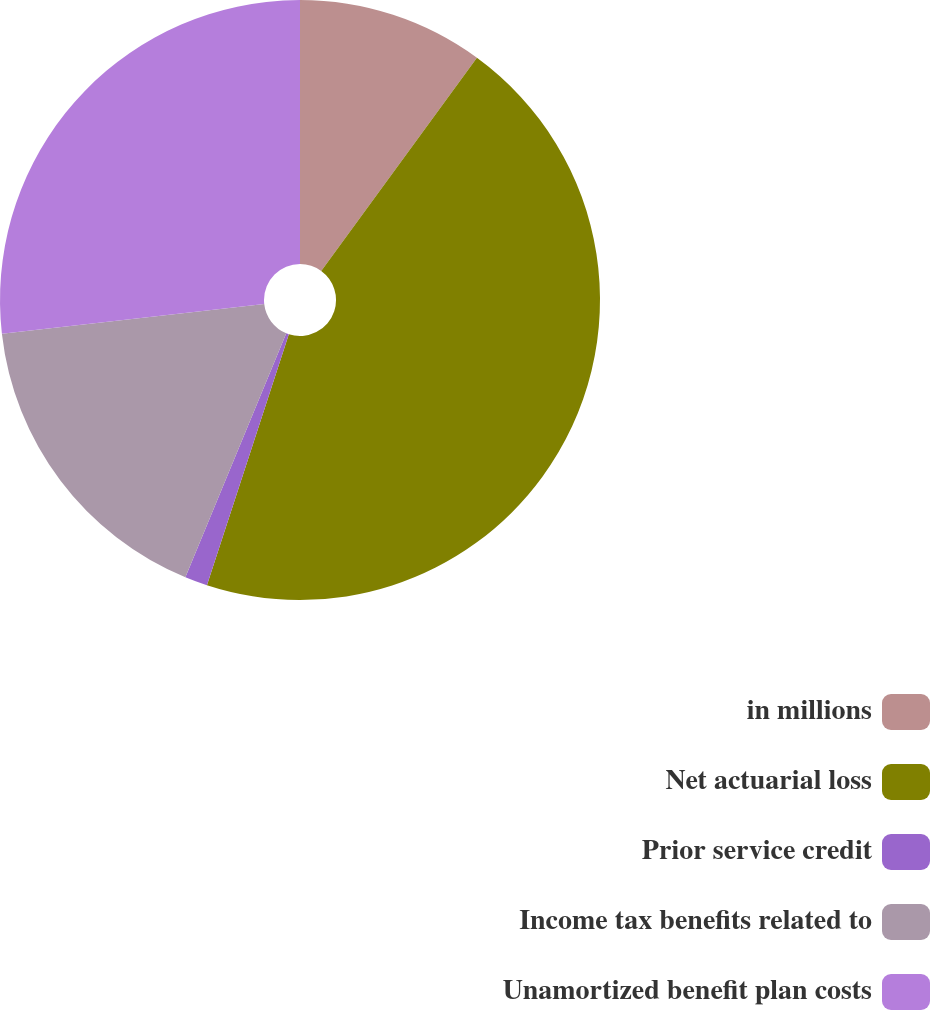Convert chart to OTSL. <chart><loc_0><loc_0><loc_500><loc_500><pie_chart><fcel>in millions<fcel>Net actuarial loss<fcel>Prior service credit<fcel>Income tax benefits related to<fcel>Unamortized benefit plan costs<nl><fcel>10.04%<fcel>44.98%<fcel>1.22%<fcel>16.97%<fcel>26.79%<nl></chart> 